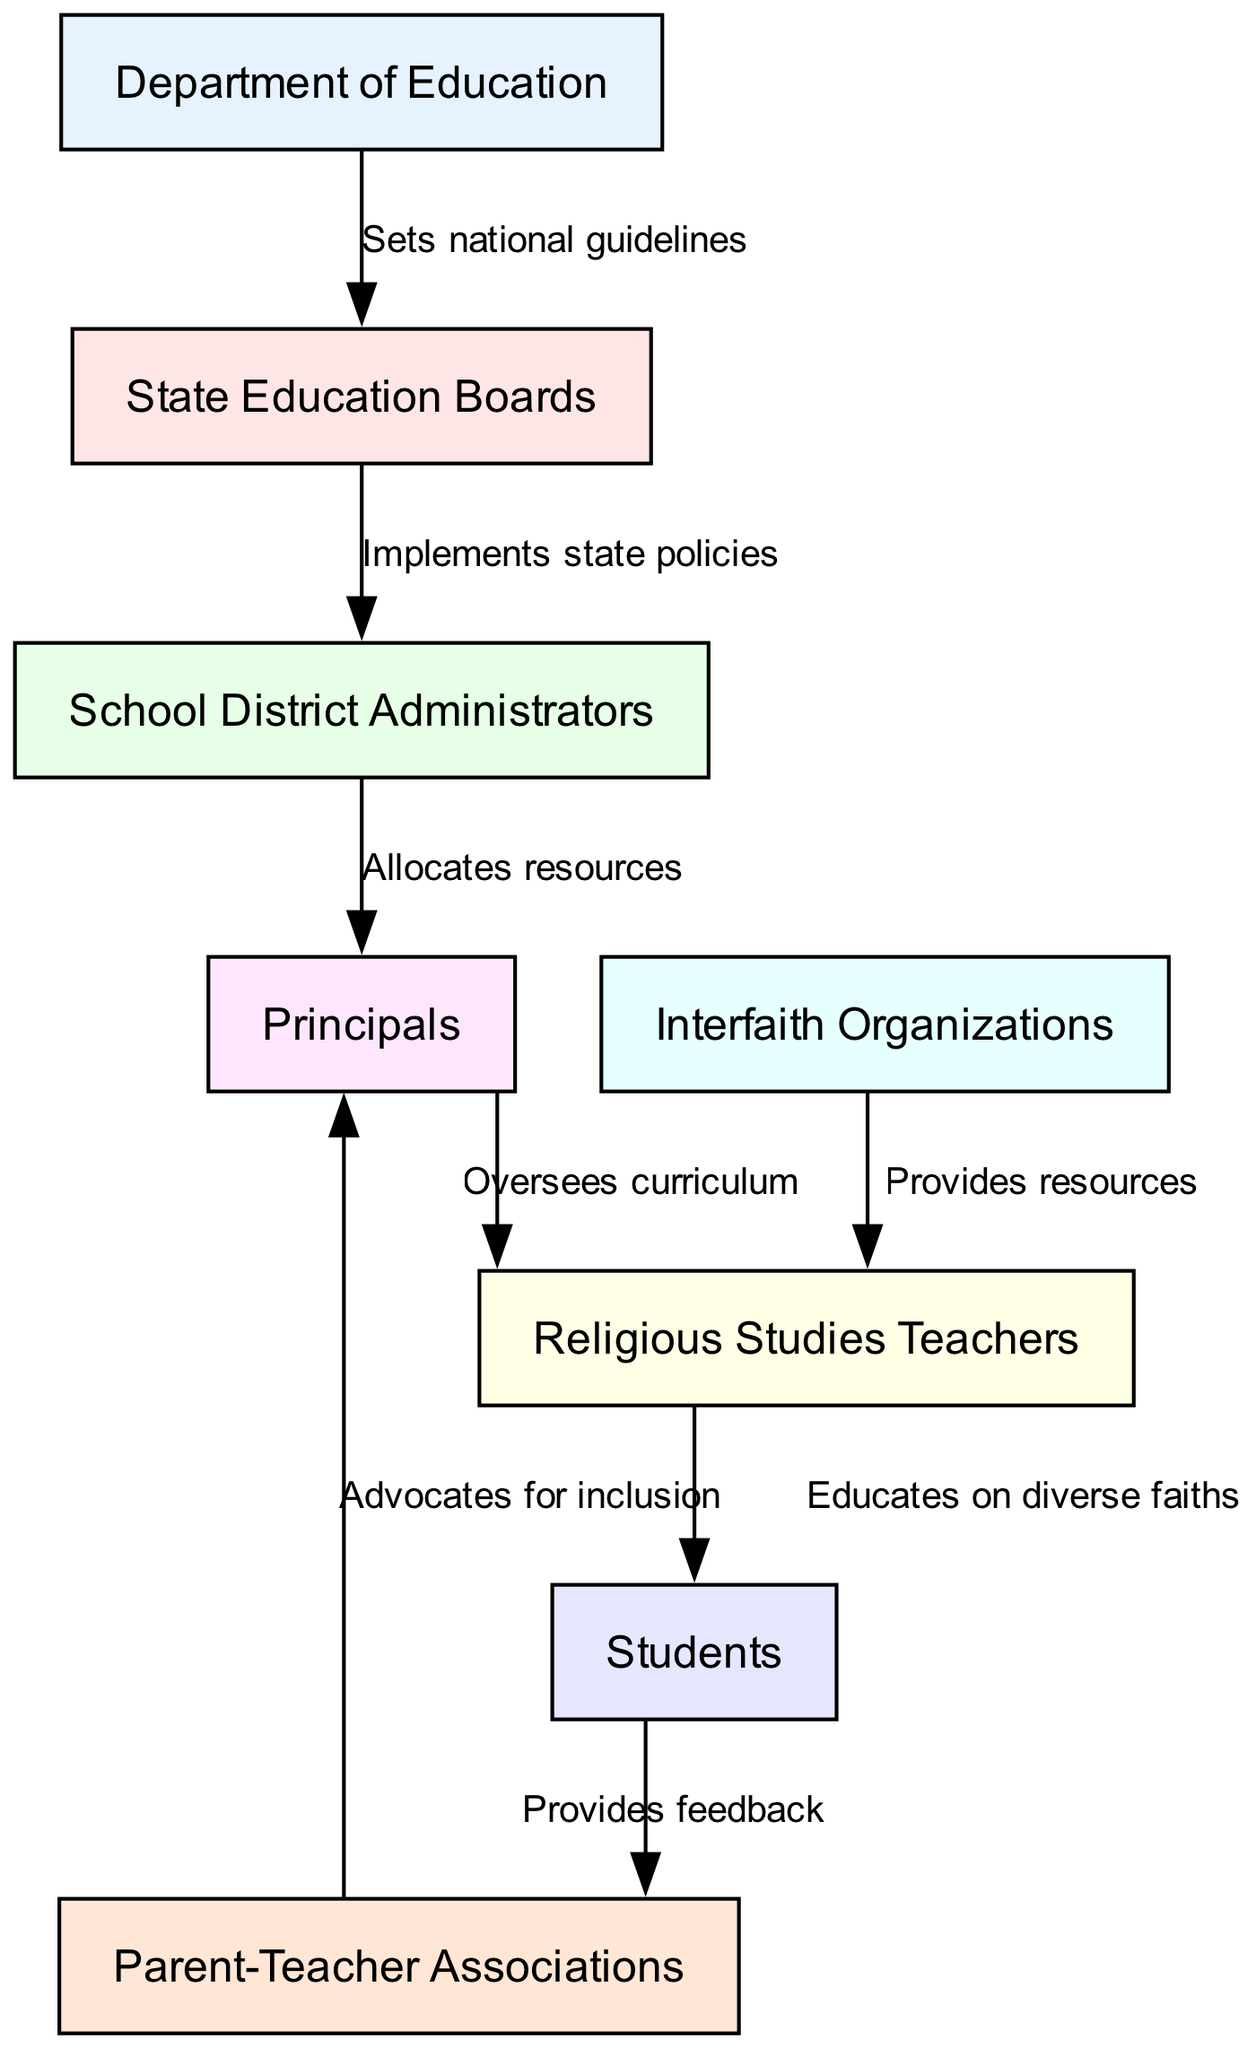What is the highest level in the hierarchy? The highest level in the hierarchy is indicated by the node that has outgoing edges leading to other stakeholders. In this case, the "Department of Education" does not receive an arrow from any other node, indicating it is at the top of the hierarchy.
Answer: Department of Education How many nodes are present in the diagram? By counting the nodes listed in the "nodes" section of the data provided, we see that there are 8 distinct stakeholders represented in the diagram.
Answer: 8 What role does "State Education Boards" have in relation to "School District Administrators"? The edge from "State Education Boards" to "School District Administrators" is labeled "Implements state policies," showing that the role of the boards is to put the policies into practice at the district level.
Answer: Implements state policies Which stakeholders provide resources to "Religious Studies Teachers"? The diagram indicates that "Interfaith Organizations" provide resources to "Religious Studies Teachers," based on the direct edge connecting the two nodes.
Answer: Interfaith Organizations How do students influence Parent-Teacher Associations? The connection from "Students" to "Parent-Teacher Associations" is marked with "Provides feedback," indicating that students have a role in giving input that influences the associations' activities or decisions.
Answer: Provides feedback What is the connection between "Principals" and "Religious Studies Teachers"? The arrow from "Principals" to "Religious Studies Teachers" is labeled "Oversees curriculum," meaning that principals are responsible for the academic content taught by the teachers, particularly in religious studies.
Answer: Oversees curriculum Which stakeholder advocates for inclusion within schools? The diagram shows that "Parent-Teacher Associations" advocate for inclusion, indicated by the edge labeled "Advocates for inclusion" directing from them to "Principals."
Answer: Parent-Teacher Associations What is the role of "School District Administrators" in the hierarchy? The "School District Administrators" manage resources at the district level, as indicated by the edge pointing to "Principals" with the label "Allocates resources," highlighting their managerial function within the educational structure.
Answer: Allocates resources How many edges are represented in the diagram? By counting the "edges" provided in the data, we can determine that there are 8 connections representing the relationships between the stakeholders in the diagram.
Answer: 8 